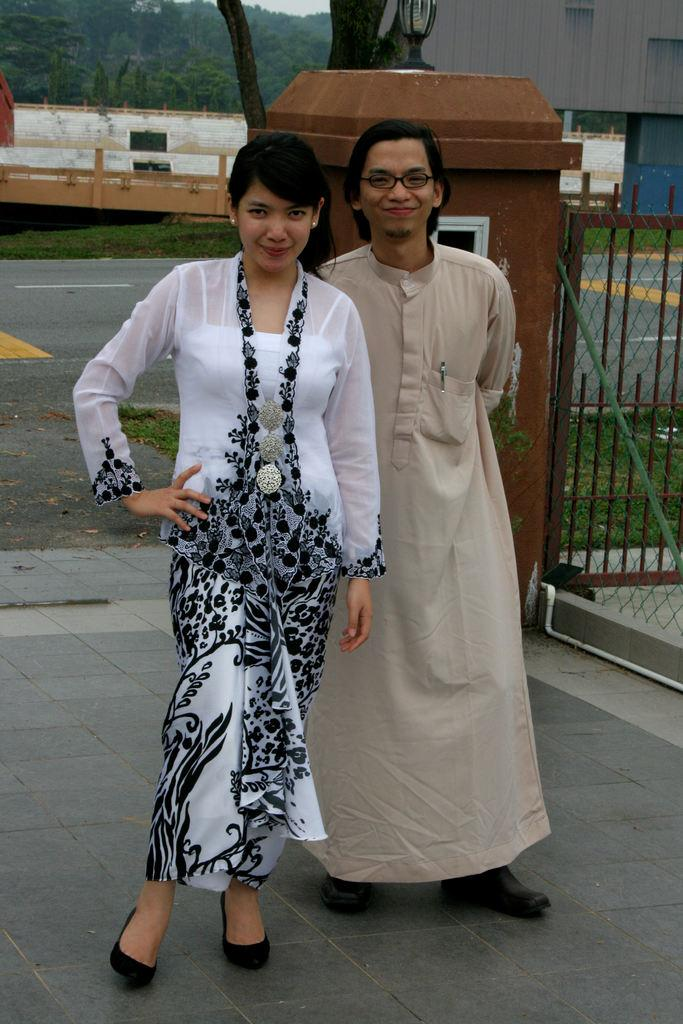How many people are in the image? There are two persons standing in the center of the image. What is the facial expression of the people in the image? The two persons are smiling. What can be seen in the background of the image? There are trees, posters, at least one building, and a fence in the background of the image. What type of throne can be seen in the image? There is no throne present in the image. How many thumbs are visible in the image? Thumbs are not mentioned or visible in the image. 